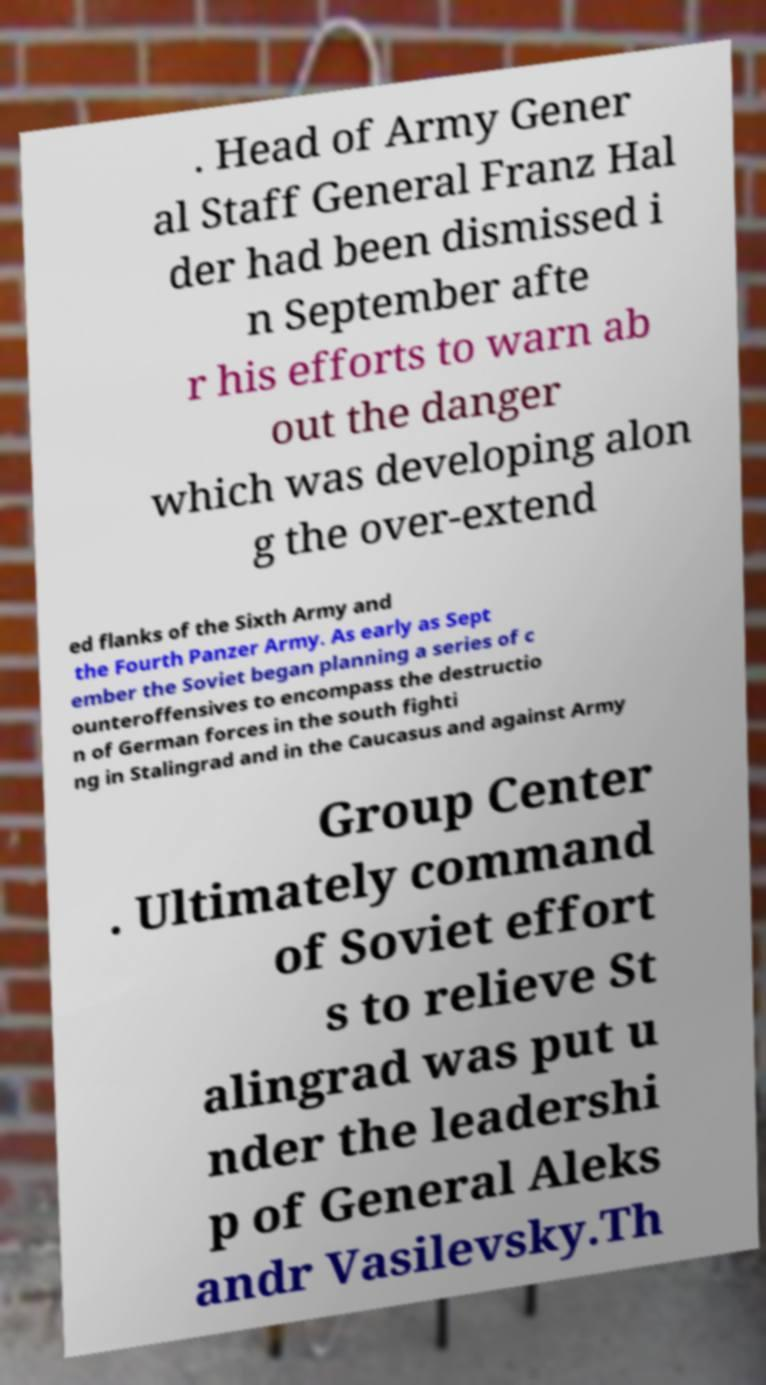Could you assist in decoding the text presented in this image and type it out clearly? . Head of Army Gener al Staff General Franz Hal der had been dismissed i n September afte r his efforts to warn ab out the danger which was developing alon g the over-extend ed flanks of the Sixth Army and the Fourth Panzer Army. As early as Sept ember the Soviet began planning a series of c ounteroffensives to encompass the destructio n of German forces in the south fighti ng in Stalingrad and in the Caucasus and against Army Group Center . Ultimately command of Soviet effort s to relieve St alingrad was put u nder the leadershi p of General Aleks andr Vasilevsky.Th 